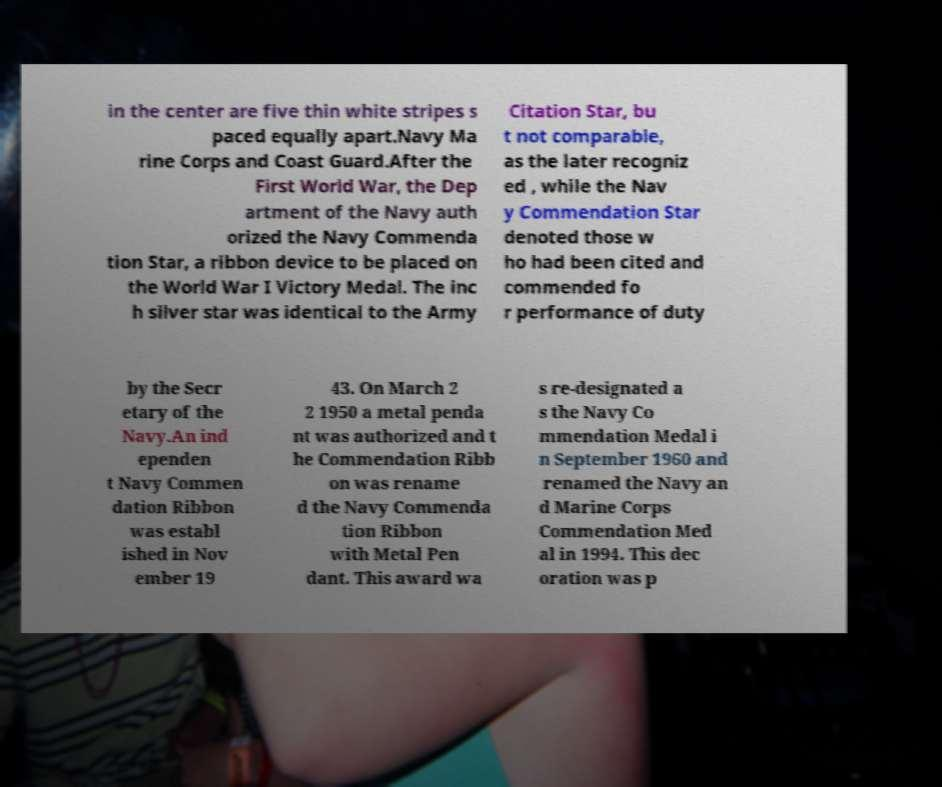Could you extract and type out the text from this image? in the center are five thin white stripes s paced equally apart.Navy Ma rine Corps and Coast Guard.After the First World War, the Dep artment of the Navy auth orized the Navy Commenda tion Star, a ribbon device to be placed on the World War I Victory Medal. The inc h silver star was identical to the Army Citation Star, bu t not comparable, as the later recogniz ed , while the Nav y Commendation Star denoted those w ho had been cited and commended fo r performance of duty by the Secr etary of the Navy.An ind ependen t Navy Commen dation Ribbon was establ ished in Nov ember 19 43. On March 2 2 1950 a metal penda nt was authorized and t he Commendation Ribb on was rename d the Navy Commenda tion Ribbon with Metal Pen dant. This award wa s re-designated a s the Navy Co mmendation Medal i n September 1960 and renamed the Navy an d Marine Corps Commendation Med al in 1994. This dec oration was p 